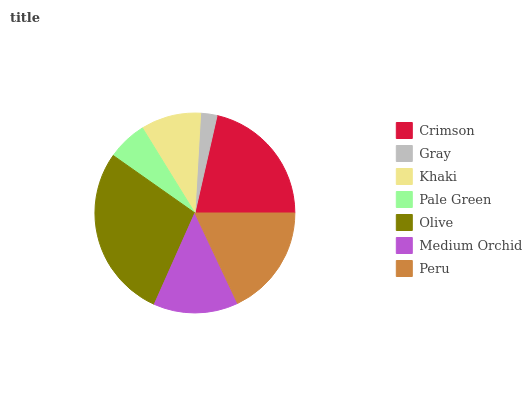Is Gray the minimum?
Answer yes or no. Yes. Is Olive the maximum?
Answer yes or no. Yes. Is Khaki the minimum?
Answer yes or no. No. Is Khaki the maximum?
Answer yes or no. No. Is Khaki greater than Gray?
Answer yes or no. Yes. Is Gray less than Khaki?
Answer yes or no. Yes. Is Gray greater than Khaki?
Answer yes or no. No. Is Khaki less than Gray?
Answer yes or no. No. Is Medium Orchid the high median?
Answer yes or no. Yes. Is Medium Orchid the low median?
Answer yes or no. Yes. Is Pale Green the high median?
Answer yes or no. No. Is Peru the low median?
Answer yes or no. No. 